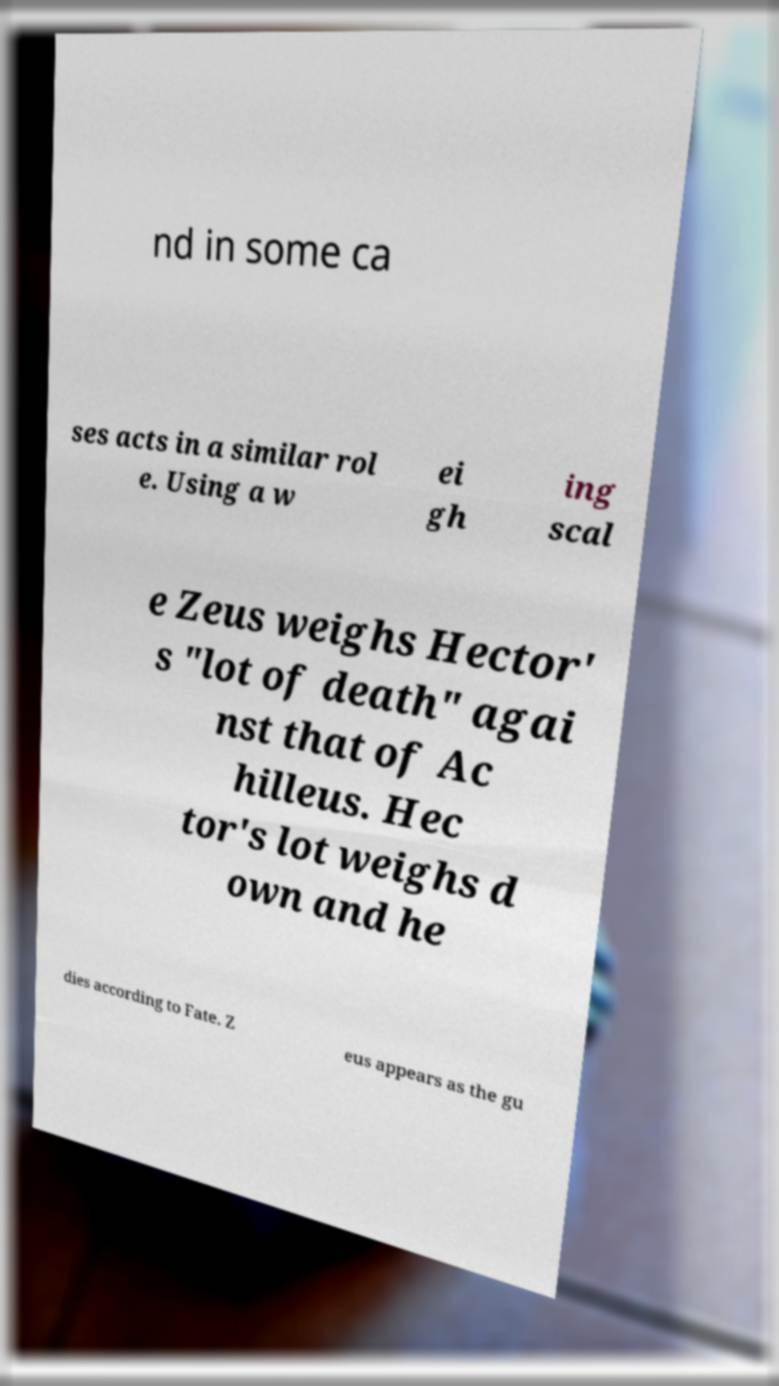Can you accurately transcribe the text from the provided image for me? nd in some ca ses acts in a similar rol e. Using a w ei gh ing scal e Zeus weighs Hector' s "lot of death" agai nst that of Ac hilleus. Hec tor's lot weighs d own and he dies according to Fate. Z eus appears as the gu 